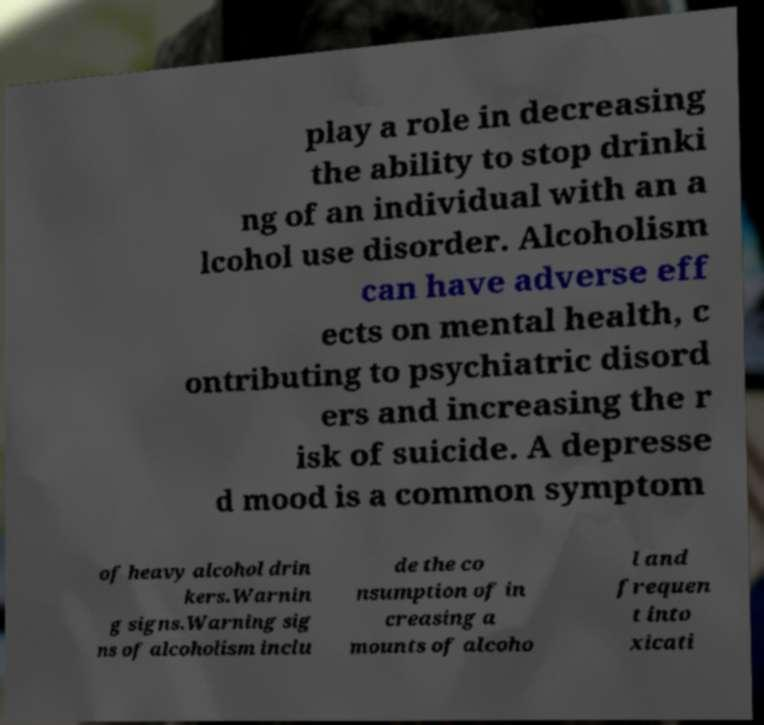Can you read and provide the text displayed in the image?This photo seems to have some interesting text. Can you extract and type it out for me? play a role in decreasing the ability to stop drinki ng of an individual with an a lcohol use disorder. Alcoholism can have adverse eff ects on mental health, c ontributing to psychiatric disord ers and increasing the r isk of suicide. A depresse d mood is a common symptom of heavy alcohol drin kers.Warnin g signs.Warning sig ns of alcoholism inclu de the co nsumption of in creasing a mounts of alcoho l and frequen t into xicati 